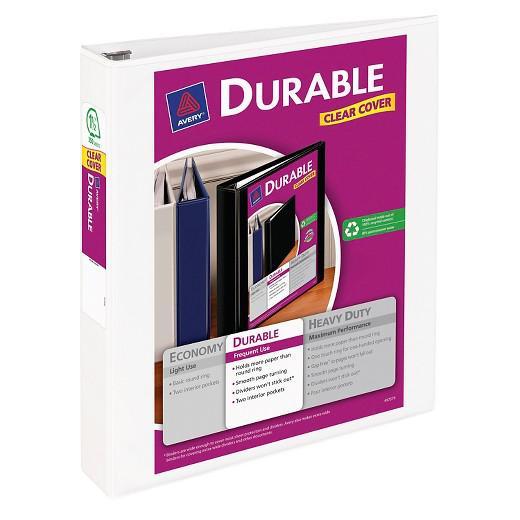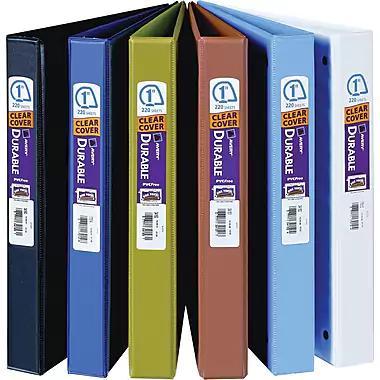The first image is the image on the left, the second image is the image on the right. For the images displayed, is the sentence "There are less than ten binders." factually correct? Answer yes or no. Yes. The first image is the image on the left, the second image is the image on the right. For the images displayed, is the sentence "There is a single binder by itself." factually correct? Answer yes or no. Yes. 